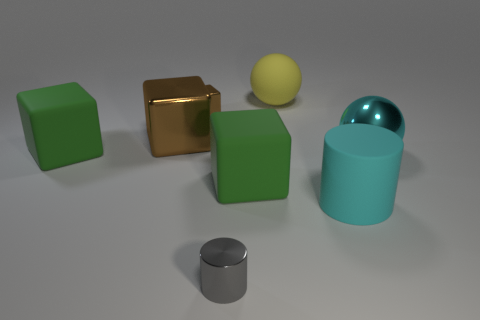What shape is the brown shiny thing that is the same size as the yellow matte ball?
Your response must be concise. Cube. How big is the gray cylinder?
Keep it short and to the point. Small. There is a cylinder that is right of the gray cylinder; is its size the same as the matte thing that is on the left side of the large brown thing?
Offer a very short reply. Yes. What color is the big ball that is on the right side of the large cylinder to the left of the big shiny ball?
Provide a short and direct response. Cyan. There is a brown cube that is the same size as the rubber sphere; what is its material?
Ensure brevity in your answer.  Metal. What number of metal objects are small gray things or large blue cylinders?
Provide a short and direct response. 1. What is the color of the metallic thing that is on the right side of the small brown thing and behind the gray object?
Ensure brevity in your answer.  Cyan. How many shiny things are on the left side of the tiny gray shiny thing?
Give a very brief answer. 2. What material is the tiny brown thing?
Offer a terse response. Metal. There is a tiny metallic object on the left side of the small object that is in front of the brown thing that is right of the large brown metallic cube; what is its color?
Ensure brevity in your answer.  Brown. 